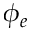<formula> <loc_0><loc_0><loc_500><loc_500>\phi _ { e }</formula> 